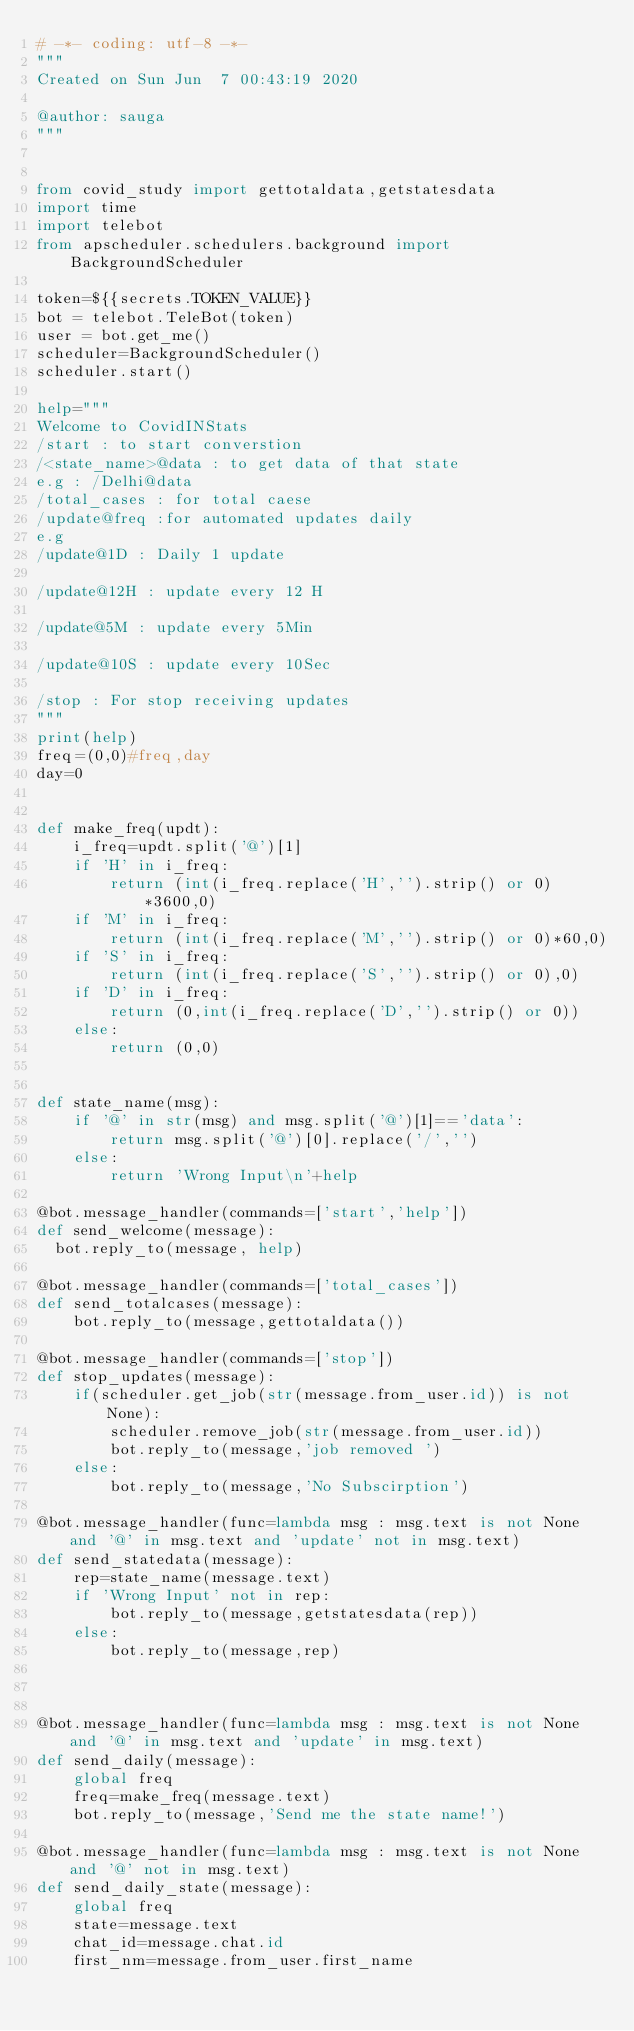<code> <loc_0><loc_0><loc_500><loc_500><_Python_># -*- coding: utf-8 -*-
"""
Created on Sun Jun  7 00:43:19 2020

@author: sauga
"""


from covid_study import gettotaldata,getstatesdata
import time
import telebot
from apscheduler.schedulers.background import BackgroundScheduler

token=${{secrets.TOKEN_VALUE}}
bot = telebot.TeleBot(token)
user = bot.get_me()
scheduler=BackgroundScheduler()
scheduler.start()

help="""
Welcome to CovidINStats
/start : to start converstion
/<state_name>@data : to get data of that state 
e.g : /Delhi@data 
/total_cases : for total caese 
/update@freq :for automated updates daily
e.g
/update@1D : Daily 1 update

/update@12H : update every 12 H

/update@5M : update every 5Min

/update@10S : update every 10Sec

/stop : For stop receiving updates
"""
print(help)
freq=(0,0)#freq,day
day=0


def make_freq(updt):
    i_freq=updt.split('@')[1]
    if 'H' in i_freq:
        return (int(i_freq.replace('H','').strip() or 0)*3600,0)
    if 'M' in i_freq:
        return (int(i_freq.replace('M','').strip() or 0)*60,0)
    if 'S' in i_freq:
        return (int(i_freq.replace('S','').strip() or 0),0)
    if 'D' in i_freq:
        return (0,int(i_freq.replace('D','').strip() or 0))
    else:
        return (0,0)
        
        
def state_name(msg):
    if '@' in str(msg) and msg.split('@')[1]=='data':
        return msg.split('@')[0].replace('/','')
    else:
        return 'Wrong Input\n'+help
        
@bot.message_handler(commands=['start','help'])
def send_welcome(message):
	bot.reply_to(message, help)

@bot.message_handler(commands=['total_cases'])
def send_totalcases(message):
    bot.reply_to(message,gettotaldata())

@bot.message_handler(commands=['stop'])
def stop_updates(message):
    if(scheduler.get_job(str(message.from_user.id)) is not None):
        scheduler.remove_job(str(message.from_user.id))
        bot.reply_to(message,'job removed ')
    else:
        bot.reply_to(message,'No Subscirption')

@bot.message_handler(func=lambda msg : msg.text is not None and '@' in msg.text and 'update' not in msg.text)
def send_statedata(message):
    rep=state_name(message.text)
    if 'Wrong Input' not in rep:
        bot.reply_to(message,getstatesdata(rep))
    else:
        bot.reply_to(message,rep)



@bot.message_handler(func=lambda msg : msg.text is not None and '@' in msg.text and 'update' in msg.text)
def send_daily(message):
    global freq
    freq=make_freq(message.text)
    bot.reply_to(message,'Send me the state name!')

@bot.message_handler(func=lambda msg : msg.text is not None and '@' not in msg.text)
def send_daily_state(message):
    global freq
    state=message.text
    chat_id=message.chat.id
    first_nm=message.from_user.first_name</code> 